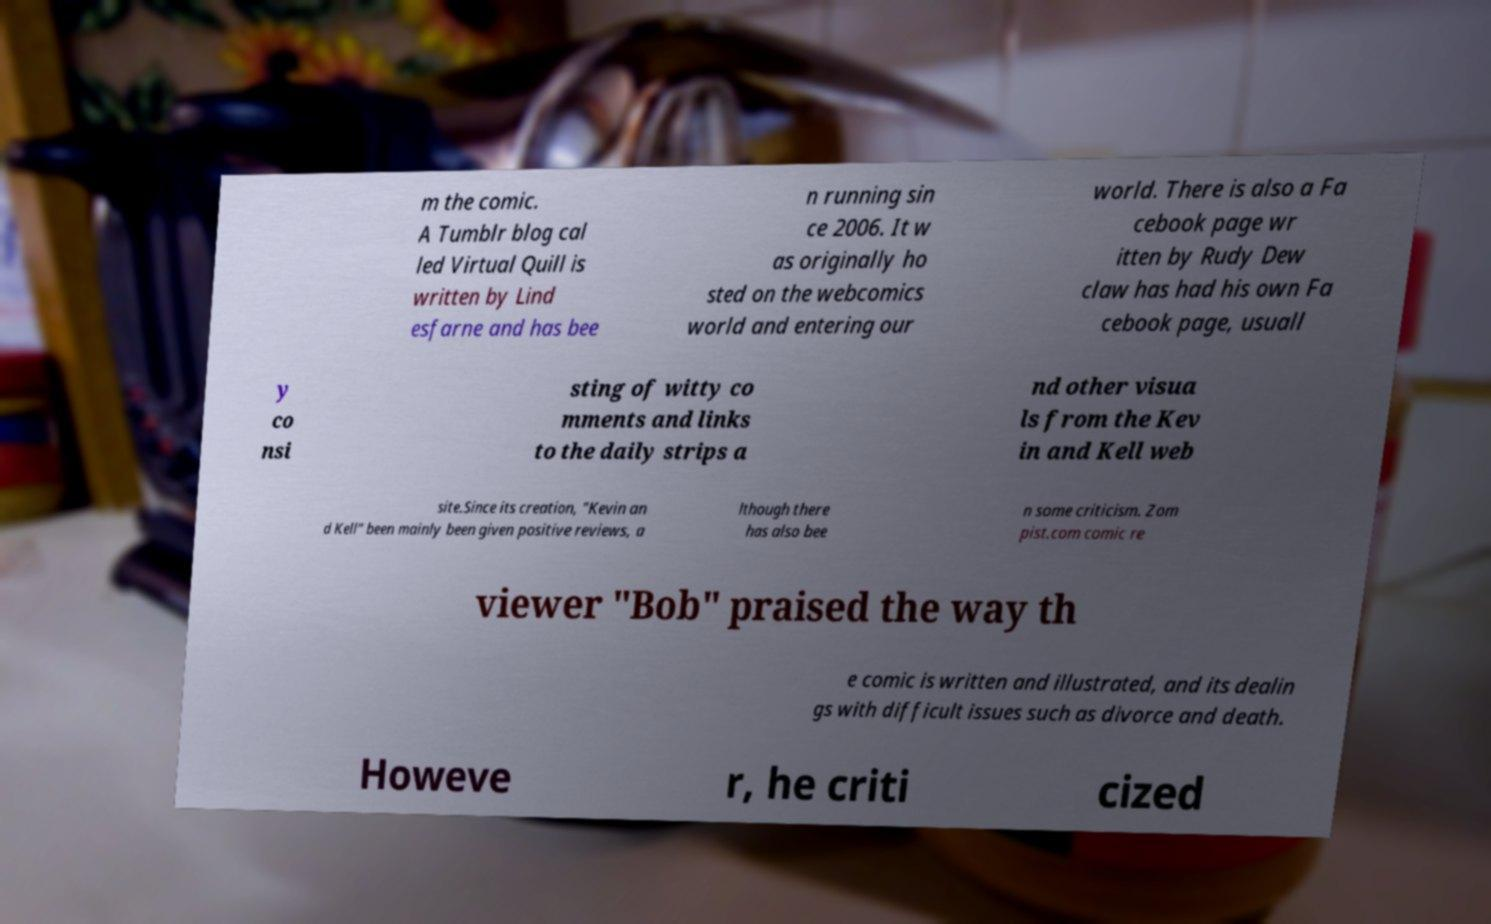Could you extract and type out the text from this image? m the comic. A Tumblr blog cal led Virtual Quill is written by Lind esfarne and has bee n running sin ce 2006. It w as originally ho sted on the webcomics world and entering our world. There is also a Fa cebook page wr itten by Rudy Dew claw has had his own Fa cebook page, usuall y co nsi sting of witty co mments and links to the daily strips a nd other visua ls from the Kev in and Kell web site.Since its creation, "Kevin an d Kell" been mainly been given positive reviews, a lthough there has also bee n some criticism. Zom pist.com comic re viewer "Bob" praised the way th e comic is written and illustrated, and its dealin gs with difficult issues such as divorce and death. Howeve r, he criti cized 